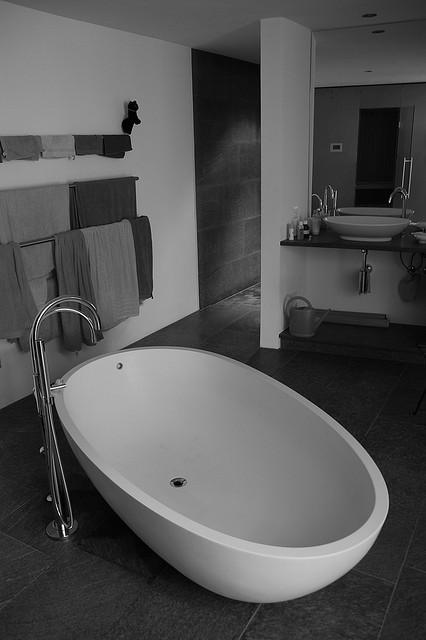Is there more than one towel?
Concise answer only. Yes. Can you shower at this place?
Quick response, please. No. What shape is the bathtub?
Write a very short answer. Oval. What is the white thing?
Answer briefly. Bathtub. 